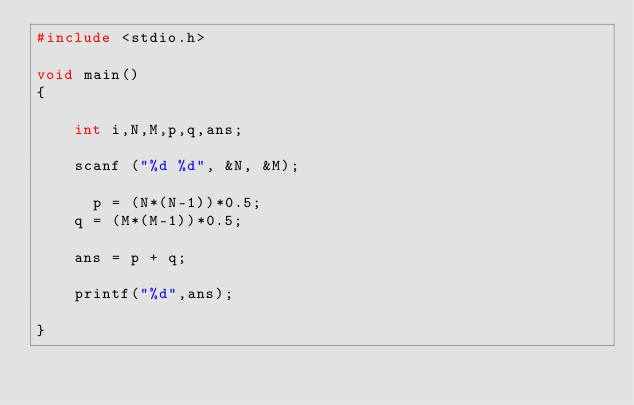Convert code to text. <code><loc_0><loc_0><loc_500><loc_500><_C_>#include <stdio.h>

void main()
{

    int i,N,M,p,q,ans;

    scanf ("%d %d", &N, &M);
  	
      p = (N*(N-1))*0.5;
  	q = (M*(M-1))*0.5;

  	ans = p + q;
  	
    printf("%d",ans);

}</code> 